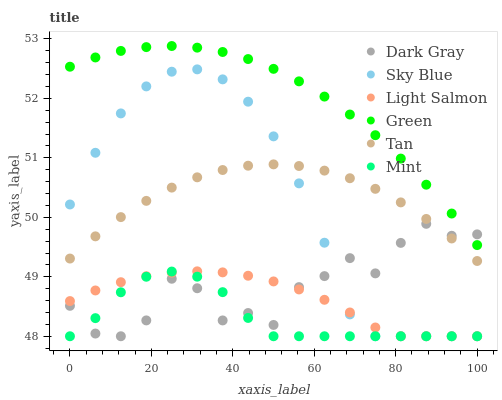Does Mint have the minimum area under the curve?
Answer yes or no. Yes. Does Green have the maximum area under the curve?
Answer yes or no. Yes. Does Dark Gray have the minimum area under the curve?
Answer yes or no. No. Does Dark Gray have the maximum area under the curve?
Answer yes or no. No. Is Light Salmon the smoothest?
Answer yes or no. Yes. Is Dark Gray the roughest?
Answer yes or no. Yes. Is Green the smoothest?
Answer yes or no. No. Is Green the roughest?
Answer yes or no. No. Does Light Salmon have the lowest value?
Answer yes or no. Yes. Does Green have the lowest value?
Answer yes or no. No. Does Green have the highest value?
Answer yes or no. Yes. Does Dark Gray have the highest value?
Answer yes or no. No. Is Light Salmon less than Tan?
Answer yes or no. Yes. Is Tan greater than Mint?
Answer yes or no. Yes. Does Dark Gray intersect Sky Blue?
Answer yes or no. Yes. Is Dark Gray less than Sky Blue?
Answer yes or no. No. Is Dark Gray greater than Sky Blue?
Answer yes or no. No. Does Light Salmon intersect Tan?
Answer yes or no. No. 